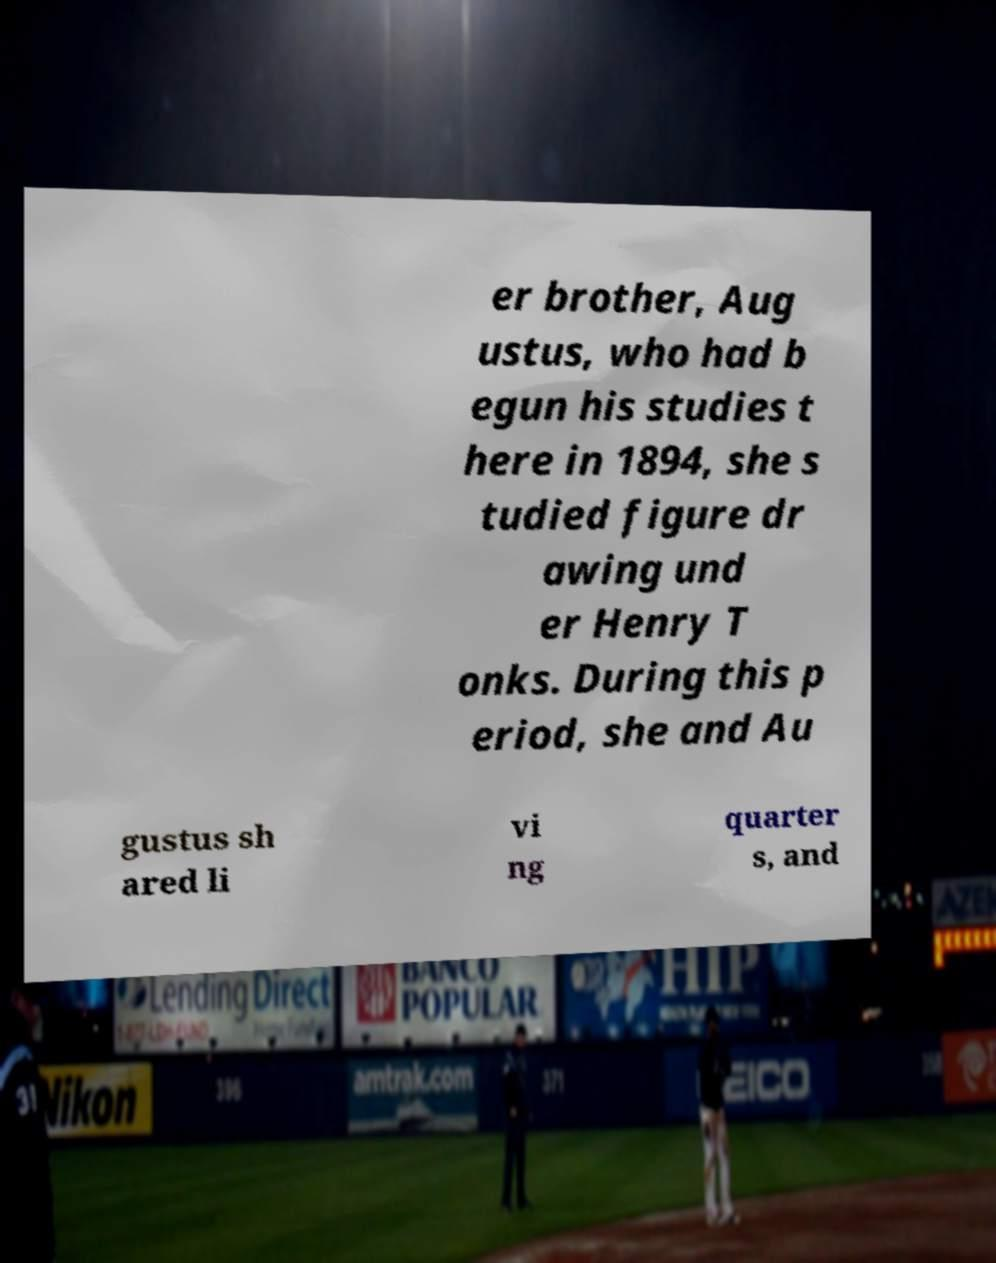What messages or text are displayed in this image? I need them in a readable, typed format. er brother, Aug ustus, who had b egun his studies t here in 1894, she s tudied figure dr awing und er Henry T onks. During this p eriod, she and Au gustus sh ared li vi ng quarter s, and 